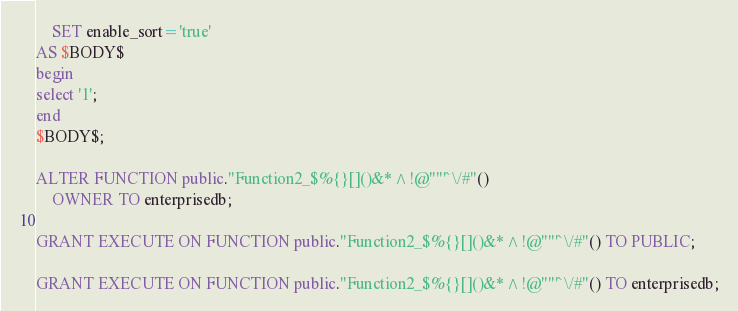<code> <loc_0><loc_0><loc_500><loc_500><_SQL_>    SET enable_sort='true'
AS $BODY$
begin
select '1';
end
$BODY$;

ALTER FUNCTION public."Function2_$%{}[]()&*^!@""'`\/#"()
    OWNER TO enterprisedb;

GRANT EXECUTE ON FUNCTION public."Function2_$%{}[]()&*^!@""'`\/#"() TO PUBLIC;

GRANT EXECUTE ON FUNCTION public."Function2_$%{}[]()&*^!@""'`\/#"() TO enterprisedb;

</code> 